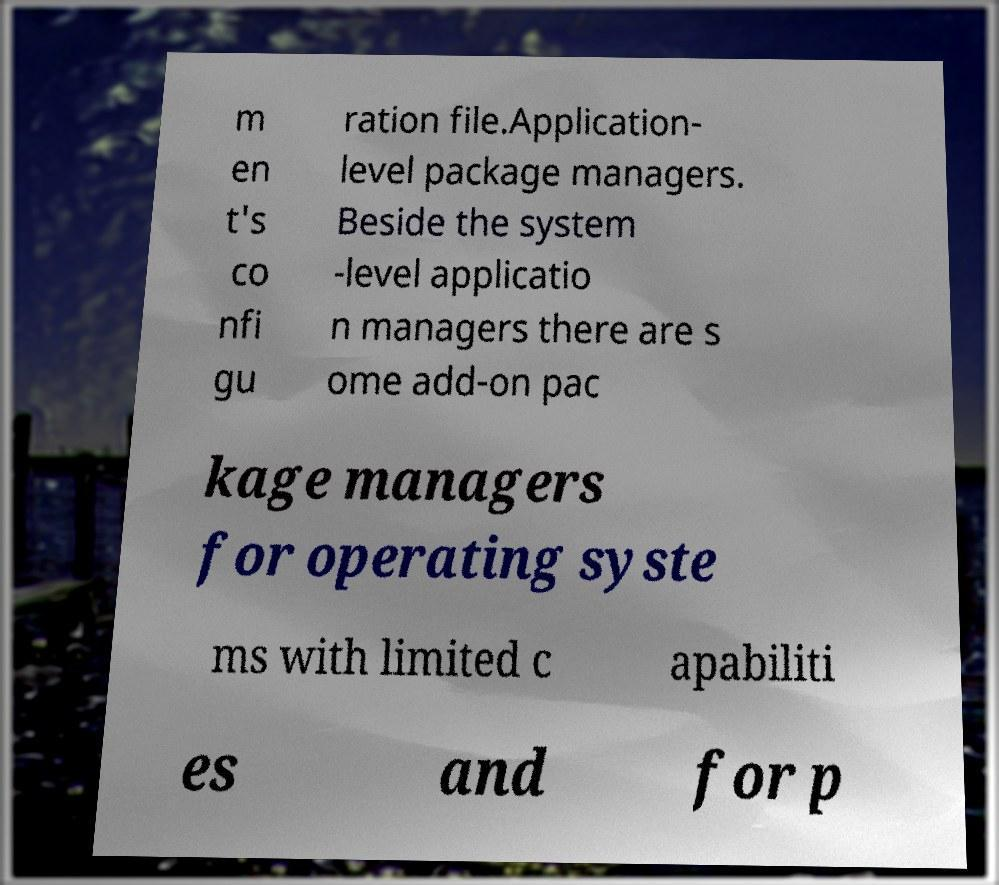Could you assist in decoding the text presented in this image and type it out clearly? m en t's co nfi gu ration file.Application- level package managers. Beside the system -level applicatio n managers there are s ome add-on pac kage managers for operating syste ms with limited c apabiliti es and for p 